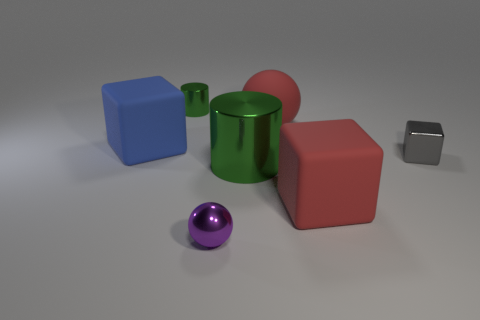There is another green thing that is the same shape as the small green object; what is it made of?
Ensure brevity in your answer.  Metal. What number of small things are either gray things or red blocks?
Give a very brief answer. 1. What material is the red sphere?
Provide a succinct answer. Rubber. There is a tiny thing that is left of the gray object and behind the small purple shiny thing; what material is it?
Your response must be concise. Metal. There is a tiny sphere; does it have the same color as the matte cube right of the tiny green shiny thing?
Make the answer very short. No. There is a green cylinder that is the same size as the gray metal object; what is it made of?
Your response must be concise. Metal. Are there any big green spheres that have the same material as the large blue thing?
Keep it short and to the point. No. How many big green metallic cubes are there?
Your answer should be very brief. 0. Is the material of the big red cube the same as the green object that is on the right side of the small metallic ball?
Give a very brief answer. No. There is a cylinder that is the same color as the big shiny object; what material is it?
Offer a very short reply. Metal. 